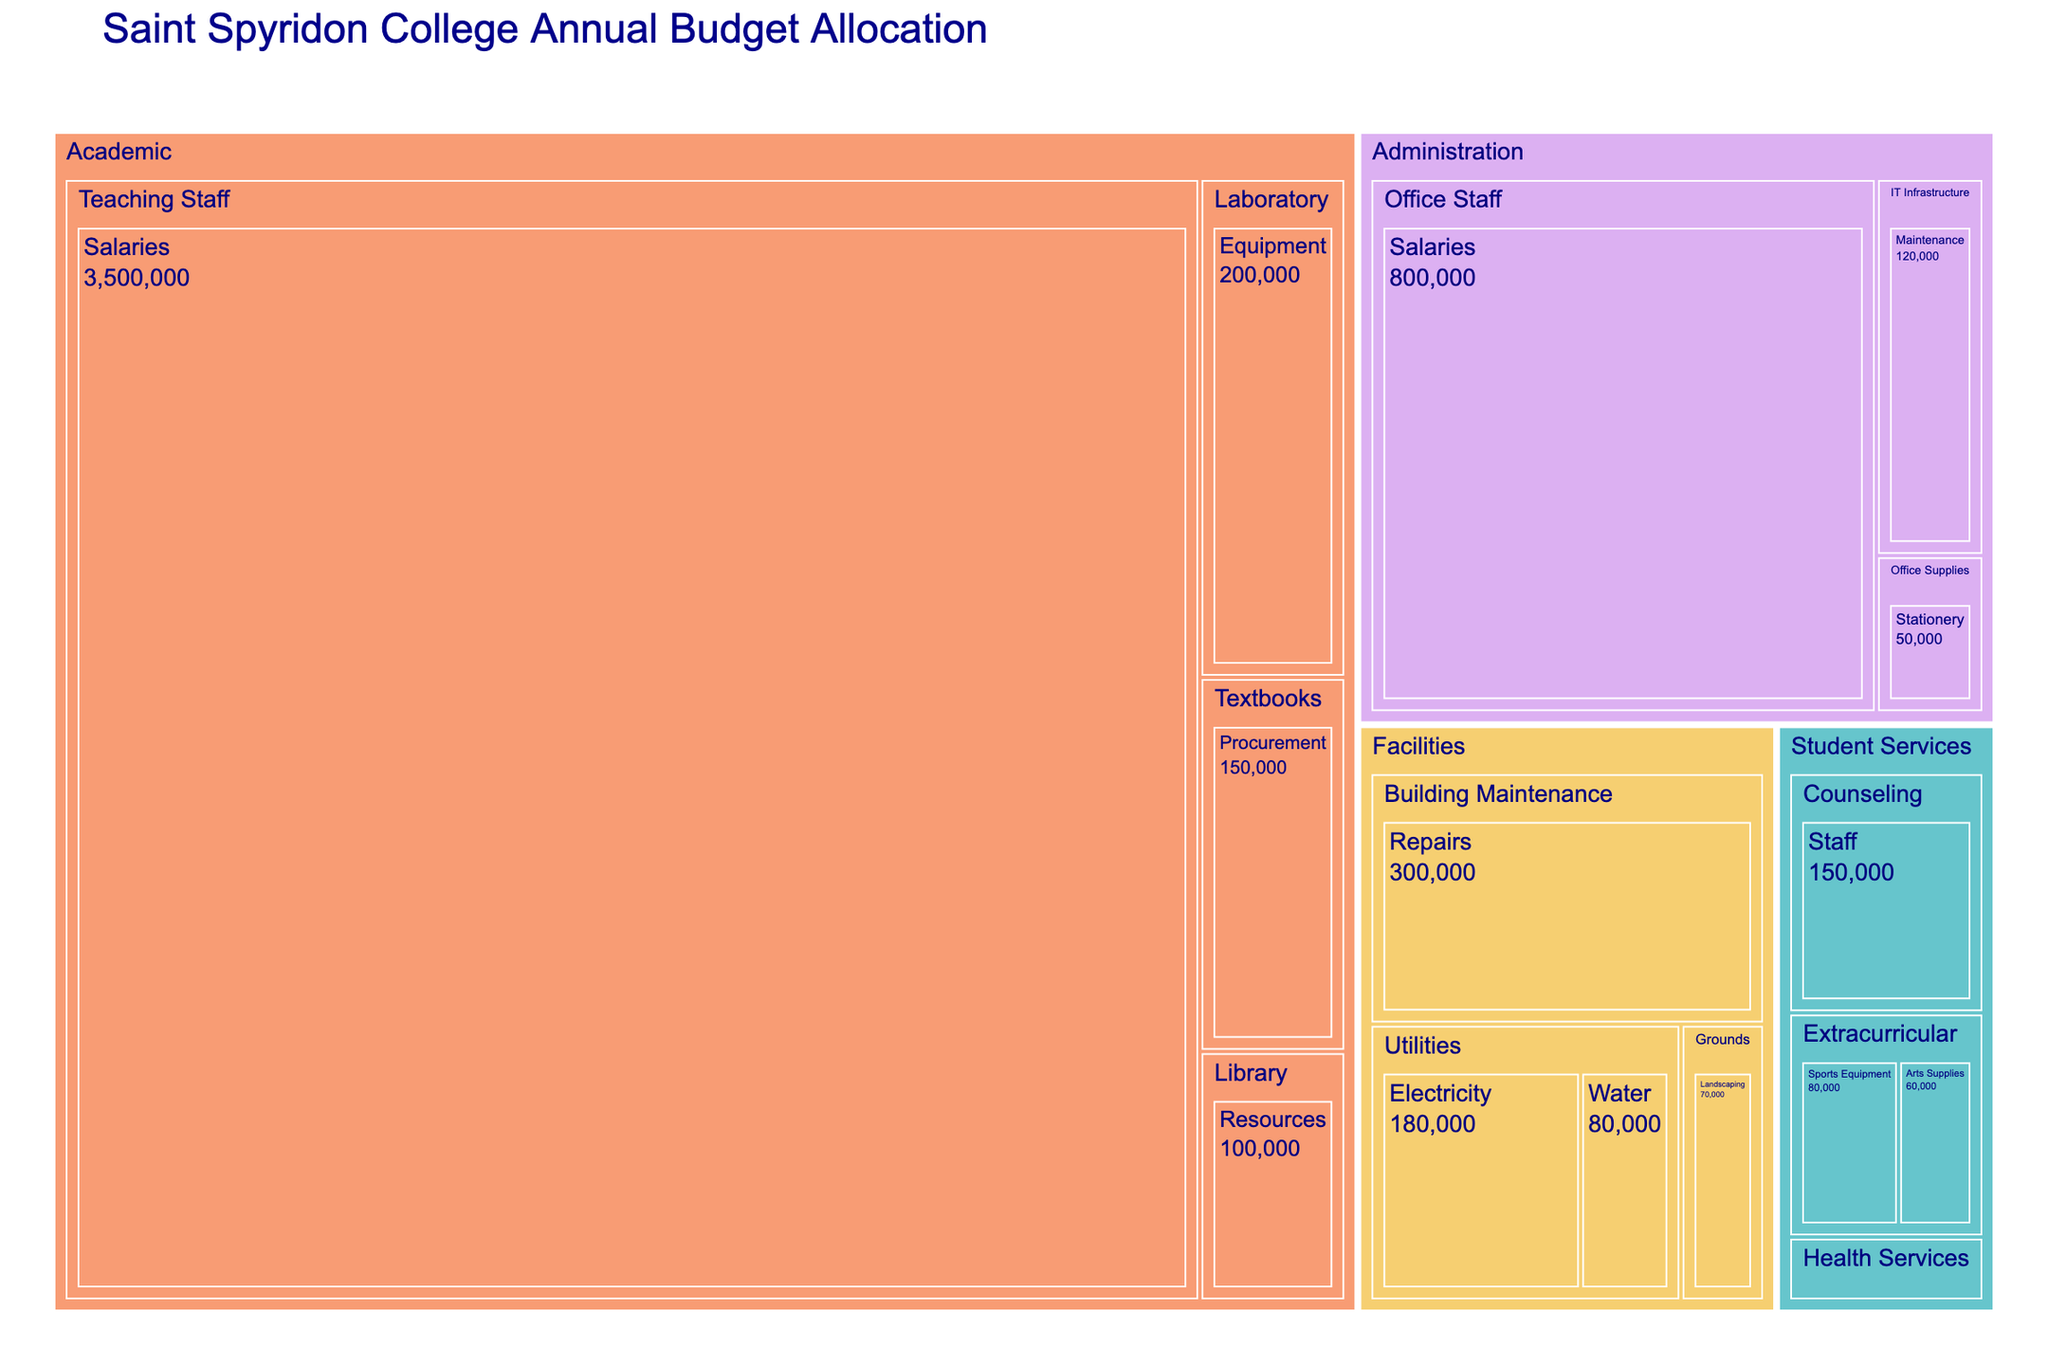What is the title of the Treemap? The title of the Treemap is usually displayed at the top of the figure. Look there to find it.
Answer: Saint Spyridon College Annual Budget Allocation Which department has the largest allocation in the budget? Look at the size of the boxes; the largest box represents the department with the highest allocation.
Answer: Academic How much is allocated to Building Maintenance under Facilities? Find the box labeled "Building Maintenance" under the "Facilities" department and note the amount.
Answer: $300,000 Which category in Student Services has the smallest budget allocation? Compare the boxes within "Student Services" and identify the smallest one.
Answer: Health Services How does the total expenditure of Utilities in Facilities compare to the total expenditure of IT Infrastructure in Administration? Calculate the total for Utilities by adding Electricity and Water, compare that to the amount for IT Infrastructure.
Answer: $260,000 vs $120,000 What is the combined budget for salaries in all departments? Add the budget for Teaching Staff Salaries, Office Staff Salaries, and Counseling Staff.
Answer: $4,450,000 How much more is spent on Teaching Staff salaries compared to Laboratory equipment? Subtract the amount for Laboratory equipment from Teaching Staff salaries.
Answer: $3,300,000 Which has a larger budget: Extracurricular activities in Student Services or Library Resources in Academic? Compare the sum of the budgets for Sports Equipment and Arts Supplies with the budget for Library Resources.
Answer: Extracurricular activities How does the budget allocation for Office Supplies in Administration compare to that of Arts Supplies in Student Services? Compare the amounts directly.
Answer: $50,000 vs $60,000 What is the total budget allocated to the Academic department? Sum the amounts of Teaching Staff Salaries, Textbooks Procurement, Laboratory Equipment, and Library Resources.
Answer: $3,850,000 